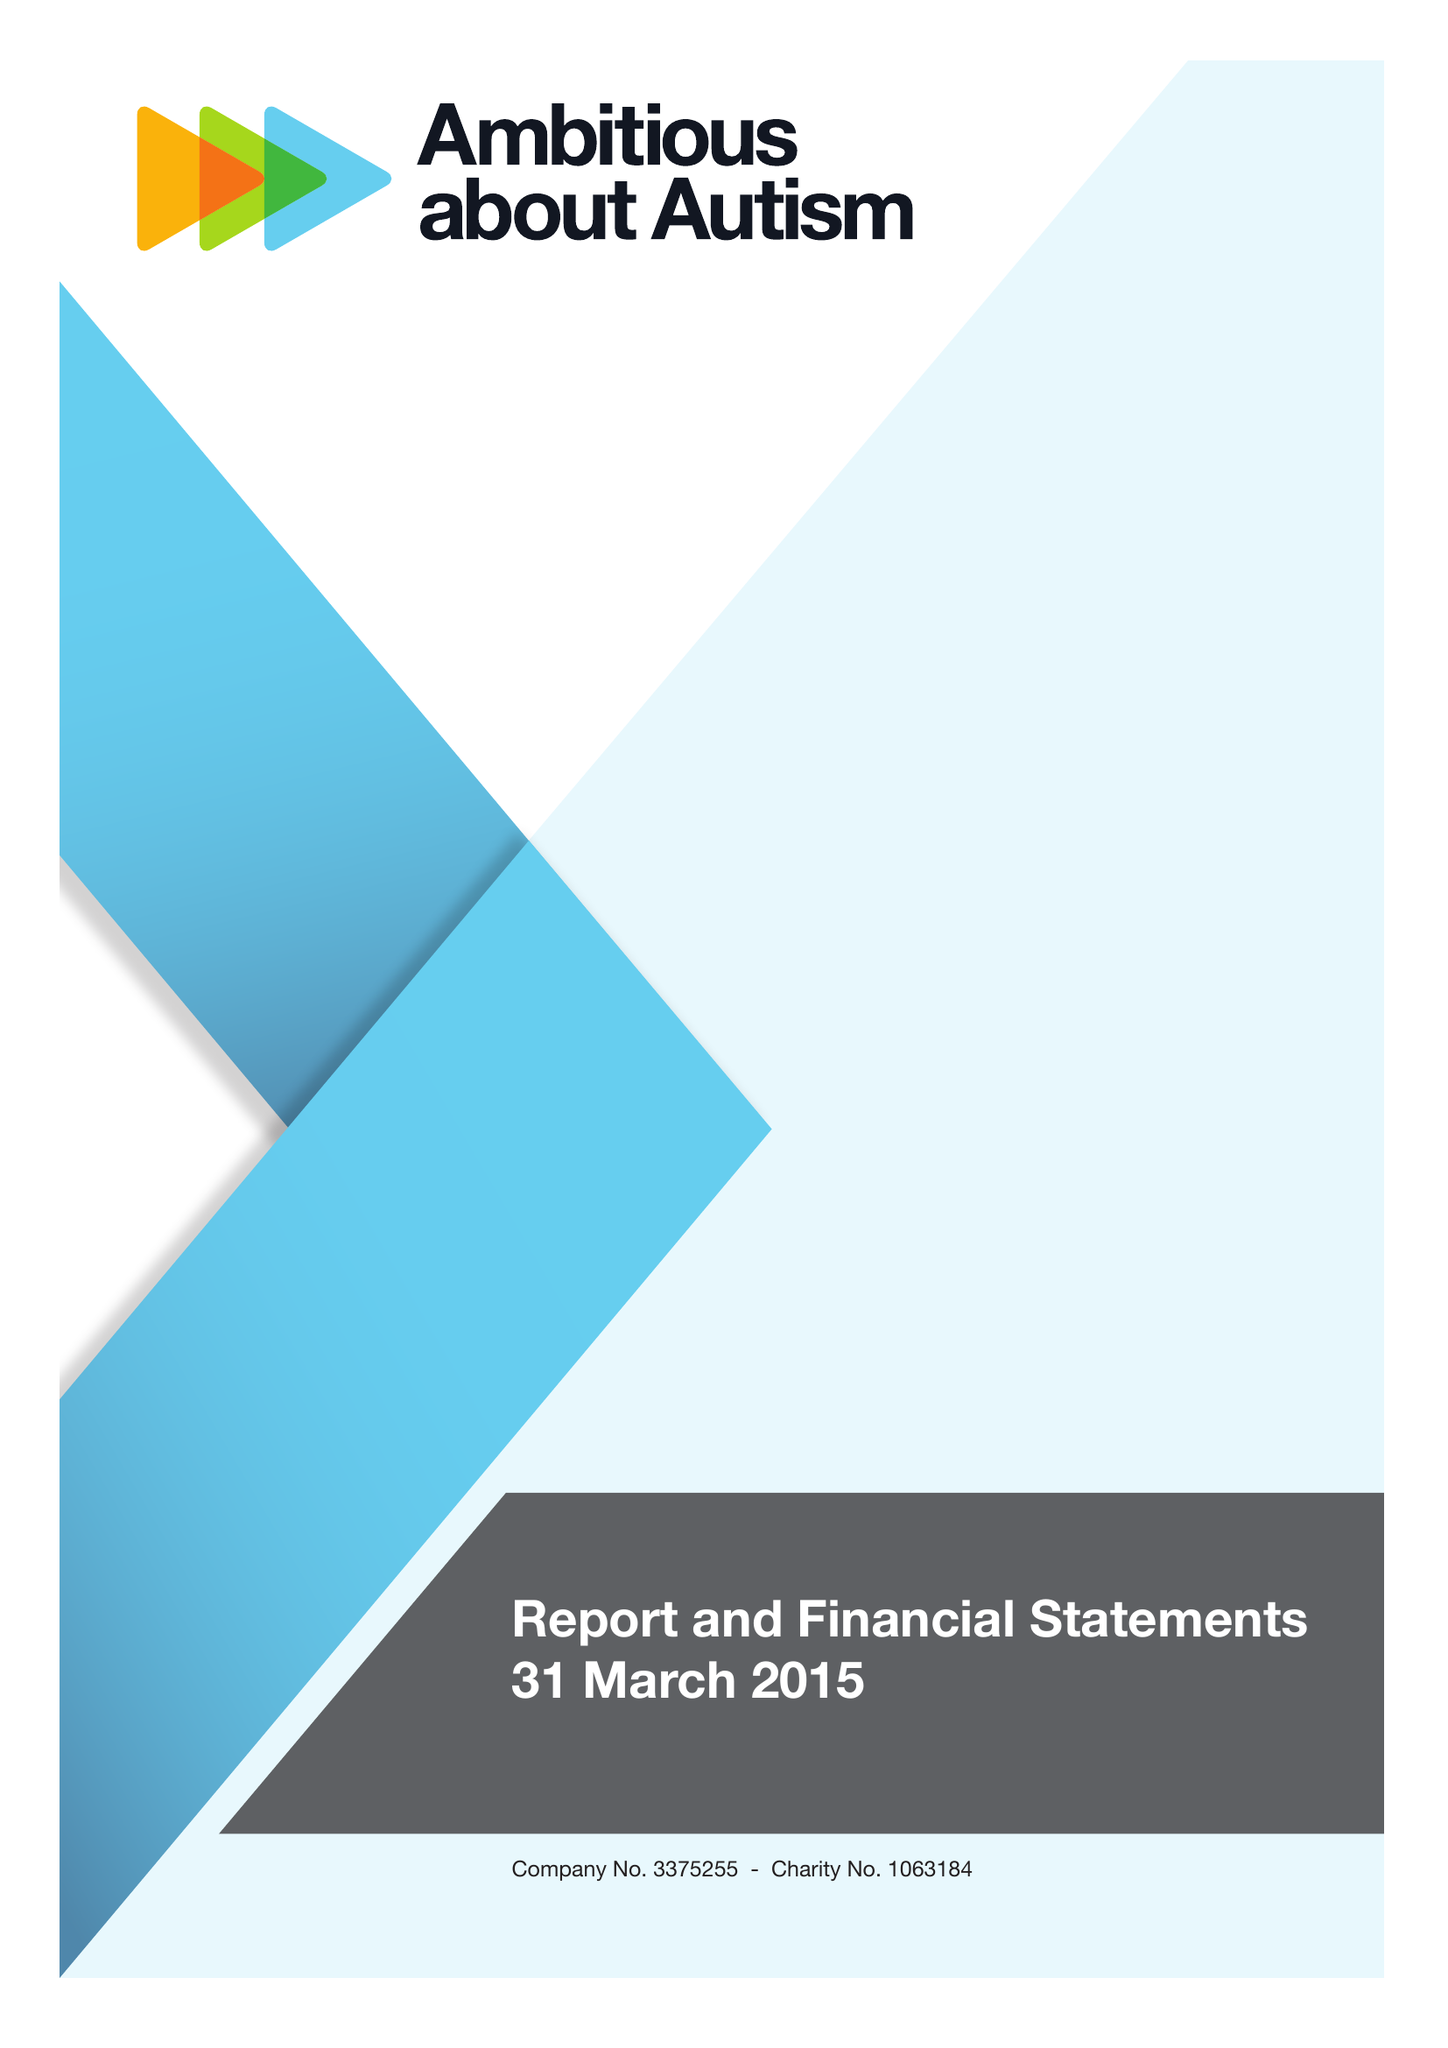What is the value for the income_annually_in_british_pounds?
Answer the question using a single word or phrase. 9739000.00 